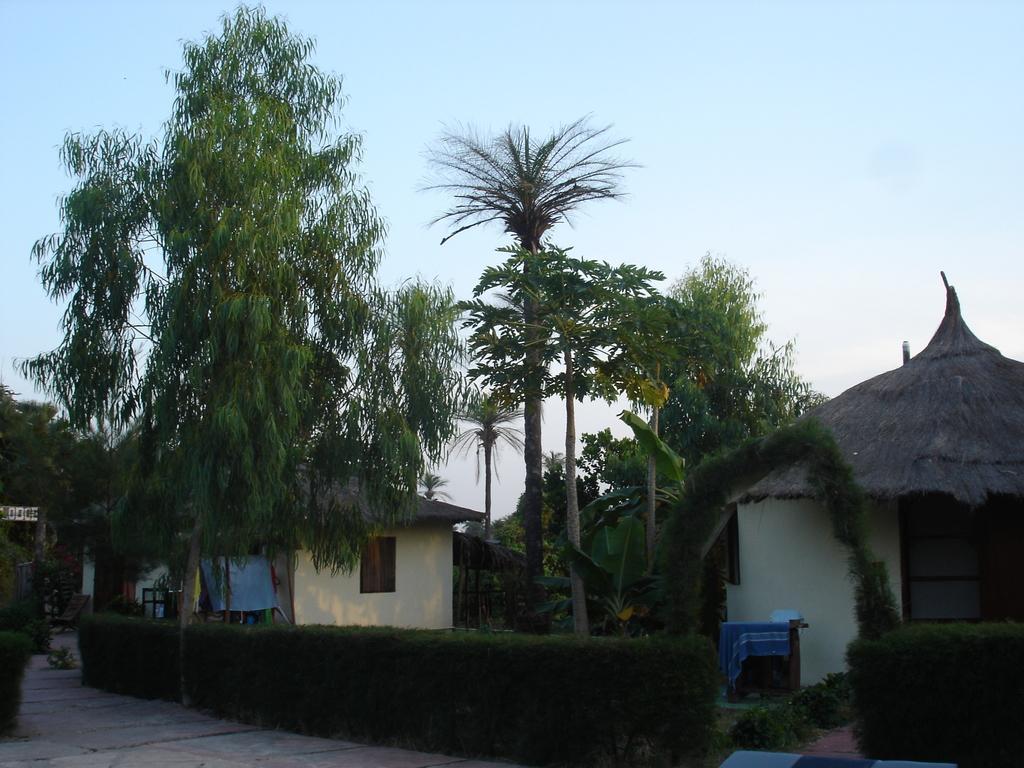Could you give a brief overview of what you see in this image? In the picture there are houses, there are trees, there is a clear sky. 